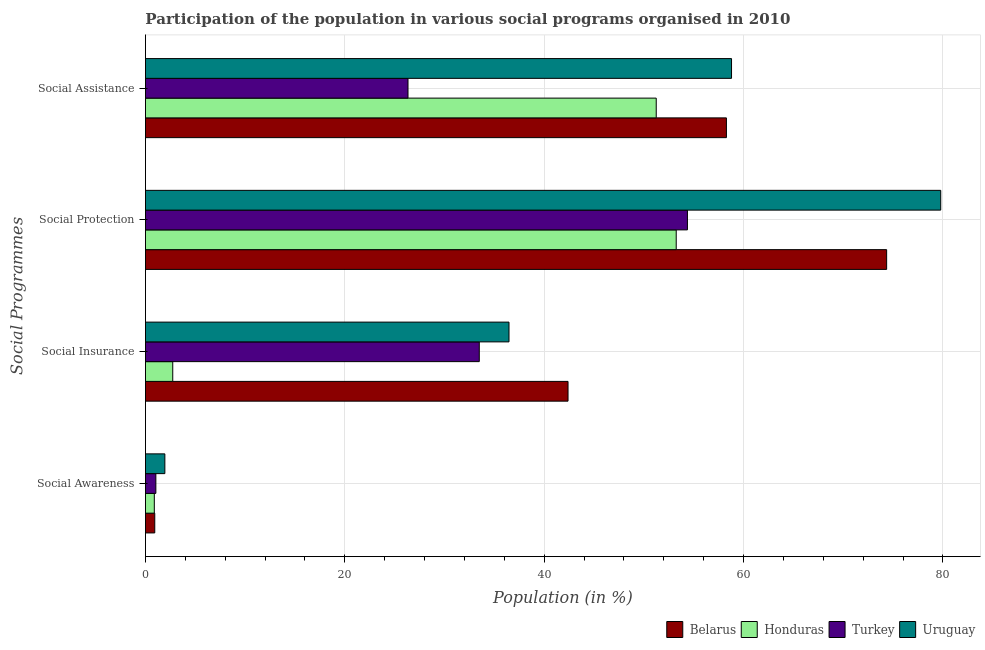How many different coloured bars are there?
Make the answer very short. 4. How many groups of bars are there?
Make the answer very short. 4. Are the number of bars per tick equal to the number of legend labels?
Offer a very short reply. Yes. Are the number of bars on each tick of the Y-axis equal?
Provide a succinct answer. Yes. How many bars are there on the 1st tick from the bottom?
Offer a very short reply. 4. What is the label of the 4th group of bars from the top?
Ensure brevity in your answer.  Social Awareness. What is the participation of population in social awareness programs in Belarus?
Your answer should be very brief. 0.93. Across all countries, what is the maximum participation of population in social assistance programs?
Provide a short and direct response. 58.79. Across all countries, what is the minimum participation of population in social insurance programs?
Provide a succinct answer. 2.74. In which country was the participation of population in social assistance programs maximum?
Your answer should be very brief. Uruguay. In which country was the participation of population in social protection programs minimum?
Your response must be concise. Honduras. What is the total participation of population in social insurance programs in the graph?
Provide a succinct answer. 115.08. What is the difference between the participation of population in social assistance programs in Uruguay and that in Turkey?
Offer a very short reply. 32.45. What is the difference between the participation of population in social protection programs in Belarus and the participation of population in social awareness programs in Turkey?
Ensure brevity in your answer.  73.31. What is the average participation of population in social protection programs per country?
Ensure brevity in your answer.  65.43. What is the difference between the participation of population in social assistance programs and participation of population in social insurance programs in Uruguay?
Make the answer very short. 22.32. What is the ratio of the participation of population in social assistance programs in Uruguay to that in Belarus?
Provide a short and direct response. 1.01. Is the difference between the participation of population in social insurance programs in Turkey and Uruguay greater than the difference between the participation of population in social awareness programs in Turkey and Uruguay?
Keep it short and to the point. No. What is the difference between the highest and the second highest participation of population in social protection programs?
Your answer should be very brief. 5.43. What is the difference between the highest and the lowest participation of population in social awareness programs?
Offer a very short reply. 1.06. Is the sum of the participation of population in social awareness programs in Belarus and Uruguay greater than the maximum participation of population in social assistance programs across all countries?
Your answer should be very brief. No. What does the 1st bar from the top in Social Awareness represents?
Offer a very short reply. Uruguay. What does the 4th bar from the bottom in Social Awareness represents?
Your answer should be very brief. Uruguay. Is it the case that in every country, the sum of the participation of population in social awareness programs and participation of population in social insurance programs is greater than the participation of population in social protection programs?
Provide a short and direct response. No. Are all the bars in the graph horizontal?
Give a very brief answer. Yes. How many countries are there in the graph?
Your answer should be very brief. 4. Does the graph contain any zero values?
Provide a succinct answer. No. Does the graph contain grids?
Ensure brevity in your answer.  Yes. Where does the legend appear in the graph?
Give a very brief answer. Bottom right. How are the legend labels stacked?
Ensure brevity in your answer.  Horizontal. What is the title of the graph?
Your answer should be compact. Participation of the population in various social programs organised in 2010. Does "Maldives" appear as one of the legend labels in the graph?
Offer a terse response. No. What is the label or title of the X-axis?
Keep it short and to the point. Population (in %). What is the label or title of the Y-axis?
Offer a very short reply. Social Programmes. What is the Population (in %) of Belarus in Social Awareness?
Provide a short and direct response. 0.93. What is the Population (in %) in Honduras in Social Awareness?
Offer a terse response. 0.89. What is the Population (in %) of Turkey in Social Awareness?
Your answer should be compact. 1.04. What is the Population (in %) in Uruguay in Social Awareness?
Your response must be concise. 1.95. What is the Population (in %) in Belarus in Social Insurance?
Your answer should be very brief. 42.39. What is the Population (in %) in Honduras in Social Insurance?
Keep it short and to the point. 2.74. What is the Population (in %) of Turkey in Social Insurance?
Give a very brief answer. 33.49. What is the Population (in %) in Uruguay in Social Insurance?
Your answer should be very brief. 36.47. What is the Population (in %) in Belarus in Social Protection?
Your answer should be compact. 74.35. What is the Population (in %) of Honduras in Social Protection?
Ensure brevity in your answer.  53.24. What is the Population (in %) of Turkey in Social Protection?
Your answer should be compact. 54.37. What is the Population (in %) in Uruguay in Social Protection?
Offer a terse response. 79.78. What is the Population (in %) in Belarus in Social Assistance?
Offer a very short reply. 58.28. What is the Population (in %) in Honduras in Social Assistance?
Ensure brevity in your answer.  51.24. What is the Population (in %) of Turkey in Social Assistance?
Offer a terse response. 26.34. What is the Population (in %) of Uruguay in Social Assistance?
Your answer should be very brief. 58.79. Across all Social Programmes, what is the maximum Population (in %) of Belarus?
Your answer should be compact. 74.35. Across all Social Programmes, what is the maximum Population (in %) of Honduras?
Your answer should be compact. 53.24. Across all Social Programmes, what is the maximum Population (in %) of Turkey?
Ensure brevity in your answer.  54.37. Across all Social Programmes, what is the maximum Population (in %) in Uruguay?
Offer a very short reply. 79.78. Across all Social Programmes, what is the minimum Population (in %) of Belarus?
Offer a very short reply. 0.93. Across all Social Programmes, what is the minimum Population (in %) in Honduras?
Ensure brevity in your answer.  0.89. Across all Social Programmes, what is the minimum Population (in %) of Turkey?
Make the answer very short. 1.04. Across all Social Programmes, what is the minimum Population (in %) in Uruguay?
Your response must be concise. 1.95. What is the total Population (in %) of Belarus in the graph?
Your answer should be very brief. 175.95. What is the total Population (in %) in Honduras in the graph?
Your answer should be compact. 108.11. What is the total Population (in %) in Turkey in the graph?
Your answer should be compact. 115.24. What is the total Population (in %) in Uruguay in the graph?
Keep it short and to the point. 176.98. What is the difference between the Population (in %) of Belarus in Social Awareness and that in Social Insurance?
Keep it short and to the point. -41.46. What is the difference between the Population (in %) of Honduras in Social Awareness and that in Social Insurance?
Your answer should be very brief. -1.85. What is the difference between the Population (in %) of Turkey in Social Awareness and that in Social Insurance?
Your response must be concise. -32.44. What is the difference between the Population (in %) of Uruguay in Social Awareness and that in Social Insurance?
Ensure brevity in your answer.  -34.52. What is the difference between the Population (in %) of Belarus in Social Awareness and that in Social Protection?
Keep it short and to the point. -73.42. What is the difference between the Population (in %) of Honduras in Social Awareness and that in Social Protection?
Offer a very short reply. -52.35. What is the difference between the Population (in %) in Turkey in Social Awareness and that in Social Protection?
Make the answer very short. -53.32. What is the difference between the Population (in %) of Uruguay in Social Awareness and that in Social Protection?
Your answer should be compact. -77.83. What is the difference between the Population (in %) in Belarus in Social Awareness and that in Social Assistance?
Offer a terse response. -57.34. What is the difference between the Population (in %) of Honduras in Social Awareness and that in Social Assistance?
Offer a terse response. -50.35. What is the difference between the Population (in %) of Turkey in Social Awareness and that in Social Assistance?
Your answer should be compact. -25.29. What is the difference between the Population (in %) of Uruguay in Social Awareness and that in Social Assistance?
Make the answer very short. -56.85. What is the difference between the Population (in %) in Belarus in Social Insurance and that in Social Protection?
Provide a succinct answer. -31.96. What is the difference between the Population (in %) in Honduras in Social Insurance and that in Social Protection?
Your answer should be compact. -50.5. What is the difference between the Population (in %) in Turkey in Social Insurance and that in Social Protection?
Provide a succinct answer. -20.88. What is the difference between the Population (in %) in Uruguay in Social Insurance and that in Social Protection?
Keep it short and to the point. -43.31. What is the difference between the Population (in %) of Belarus in Social Insurance and that in Social Assistance?
Give a very brief answer. -15.89. What is the difference between the Population (in %) of Honduras in Social Insurance and that in Social Assistance?
Your answer should be compact. -48.5. What is the difference between the Population (in %) of Turkey in Social Insurance and that in Social Assistance?
Your answer should be very brief. 7.15. What is the difference between the Population (in %) in Uruguay in Social Insurance and that in Social Assistance?
Offer a terse response. -22.32. What is the difference between the Population (in %) in Belarus in Social Protection and that in Social Assistance?
Provide a short and direct response. 16.07. What is the difference between the Population (in %) in Honduras in Social Protection and that in Social Assistance?
Keep it short and to the point. 2. What is the difference between the Population (in %) in Turkey in Social Protection and that in Social Assistance?
Provide a short and direct response. 28.03. What is the difference between the Population (in %) of Uruguay in Social Protection and that in Social Assistance?
Offer a terse response. 20.98. What is the difference between the Population (in %) of Belarus in Social Awareness and the Population (in %) of Honduras in Social Insurance?
Provide a short and direct response. -1.8. What is the difference between the Population (in %) of Belarus in Social Awareness and the Population (in %) of Turkey in Social Insurance?
Your answer should be compact. -32.55. What is the difference between the Population (in %) in Belarus in Social Awareness and the Population (in %) in Uruguay in Social Insurance?
Make the answer very short. -35.53. What is the difference between the Population (in %) in Honduras in Social Awareness and the Population (in %) in Turkey in Social Insurance?
Keep it short and to the point. -32.6. What is the difference between the Population (in %) of Honduras in Social Awareness and the Population (in %) of Uruguay in Social Insurance?
Provide a succinct answer. -35.58. What is the difference between the Population (in %) of Turkey in Social Awareness and the Population (in %) of Uruguay in Social Insurance?
Make the answer very short. -35.42. What is the difference between the Population (in %) of Belarus in Social Awareness and the Population (in %) of Honduras in Social Protection?
Provide a succinct answer. -52.31. What is the difference between the Population (in %) of Belarus in Social Awareness and the Population (in %) of Turkey in Social Protection?
Give a very brief answer. -53.43. What is the difference between the Population (in %) in Belarus in Social Awareness and the Population (in %) in Uruguay in Social Protection?
Keep it short and to the point. -78.84. What is the difference between the Population (in %) of Honduras in Social Awareness and the Population (in %) of Turkey in Social Protection?
Offer a terse response. -53.48. What is the difference between the Population (in %) in Honduras in Social Awareness and the Population (in %) in Uruguay in Social Protection?
Keep it short and to the point. -78.89. What is the difference between the Population (in %) of Turkey in Social Awareness and the Population (in %) of Uruguay in Social Protection?
Your answer should be very brief. -78.73. What is the difference between the Population (in %) in Belarus in Social Awareness and the Population (in %) in Honduras in Social Assistance?
Make the answer very short. -50.3. What is the difference between the Population (in %) of Belarus in Social Awareness and the Population (in %) of Turkey in Social Assistance?
Ensure brevity in your answer.  -25.4. What is the difference between the Population (in %) of Belarus in Social Awareness and the Population (in %) of Uruguay in Social Assistance?
Keep it short and to the point. -57.86. What is the difference between the Population (in %) of Honduras in Social Awareness and the Population (in %) of Turkey in Social Assistance?
Your answer should be very brief. -25.45. What is the difference between the Population (in %) of Honduras in Social Awareness and the Population (in %) of Uruguay in Social Assistance?
Your response must be concise. -57.9. What is the difference between the Population (in %) in Turkey in Social Awareness and the Population (in %) in Uruguay in Social Assistance?
Ensure brevity in your answer.  -57.75. What is the difference between the Population (in %) of Belarus in Social Insurance and the Population (in %) of Honduras in Social Protection?
Provide a succinct answer. -10.85. What is the difference between the Population (in %) in Belarus in Social Insurance and the Population (in %) in Turkey in Social Protection?
Ensure brevity in your answer.  -11.98. What is the difference between the Population (in %) of Belarus in Social Insurance and the Population (in %) of Uruguay in Social Protection?
Your answer should be compact. -37.39. What is the difference between the Population (in %) in Honduras in Social Insurance and the Population (in %) in Turkey in Social Protection?
Make the answer very short. -51.63. What is the difference between the Population (in %) of Honduras in Social Insurance and the Population (in %) of Uruguay in Social Protection?
Your response must be concise. -77.04. What is the difference between the Population (in %) of Turkey in Social Insurance and the Population (in %) of Uruguay in Social Protection?
Provide a succinct answer. -46.29. What is the difference between the Population (in %) in Belarus in Social Insurance and the Population (in %) in Honduras in Social Assistance?
Make the answer very short. -8.85. What is the difference between the Population (in %) in Belarus in Social Insurance and the Population (in %) in Turkey in Social Assistance?
Your response must be concise. 16.05. What is the difference between the Population (in %) of Belarus in Social Insurance and the Population (in %) of Uruguay in Social Assistance?
Your response must be concise. -16.4. What is the difference between the Population (in %) of Honduras in Social Insurance and the Population (in %) of Turkey in Social Assistance?
Make the answer very short. -23.6. What is the difference between the Population (in %) of Honduras in Social Insurance and the Population (in %) of Uruguay in Social Assistance?
Provide a succinct answer. -56.05. What is the difference between the Population (in %) in Turkey in Social Insurance and the Population (in %) in Uruguay in Social Assistance?
Provide a short and direct response. -25.3. What is the difference between the Population (in %) of Belarus in Social Protection and the Population (in %) of Honduras in Social Assistance?
Provide a short and direct response. 23.11. What is the difference between the Population (in %) of Belarus in Social Protection and the Population (in %) of Turkey in Social Assistance?
Provide a succinct answer. 48.01. What is the difference between the Population (in %) of Belarus in Social Protection and the Population (in %) of Uruguay in Social Assistance?
Keep it short and to the point. 15.56. What is the difference between the Population (in %) of Honduras in Social Protection and the Population (in %) of Turkey in Social Assistance?
Ensure brevity in your answer.  26.91. What is the difference between the Population (in %) of Honduras in Social Protection and the Population (in %) of Uruguay in Social Assistance?
Offer a very short reply. -5.55. What is the difference between the Population (in %) in Turkey in Social Protection and the Population (in %) in Uruguay in Social Assistance?
Ensure brevity in your answer.  -4.42. What is the average Population (in %) in Belarus per Social Programmes?
Offer a terse response. 43.99. What is the average Population (in %) in Honduras per Social Programmes?
Offer a terse response. 27.03. What is the average Population (in %) in Turkey per Social Programmes?
Your answer should be compact. 28.81. What is the average Population (in %) in Uruguay per Social Programmes?
Your answer should be compact. 44.25. What is the difference between the Population (in %) of Belarus and Population (in %) of Honduras in Social Awareness?
Provide a short and direct response. 0.04. What is the difference between the Population (in %) of Belarus and Population (in %) of Turkey in Social Awareness?
Your answer should be compact. -0.11. What is the difference between the Population (in %) of Belarus and Population (in %) of Uruguay in Social Awareness?
Your answer should be compact. -1.01. What is the difference between the Population (in %) of Honduras and Population (in %) of Turkey in Social Awareness?
Provide a short and direct response. -0.16. What is the difference between the Population (in %) in Honduras and Population (in %) in Uruguay in Social Awareness?
Provide a short and direct response. -1.06. What is the difference between the Population (in %) of Turkey and Population (in %) of Uruguay in Social Awareness?
Give a very brief answer. -0.9. What is the difference between the Population (in %) of Belarus and Population (in %) of Honduras in Social Insurance?
Offer a terse response. 39.65. What is the difference between the Population (in %) of Belarus and Population (in %) of Turkey in Social Insurance?
Provide a short and direct response. 8.9. What is the difference between the Population (in %) of Belarus and Population (in %) of Uruguay in Social Insurance?
Provide a succinct answer. 5.92. What is the difference between the Population (in %) in Honduras and Population (in %) in Turkey in Social Insurance?
Offer a very short reply. -30.75. What is the difference between the Population (in %) in Honduras and Population (in %) in Uruguay in Social Insurance?
Offer a very short reply. -33.73. What is the difference between the Population (in %) in Turkey and Population (in %) in Uruguay in Social Insurance?
Ensure brevity in your answer.  -2.98. What is the difference between the Population (in %) of Belarus and Population (in %) of Honduras in Social Protection?
Give a very brief answer. 21.11. What is the difference between the Population (in %) of Belarus and Population (in %) of Turkey in Social Protection?
Give a very brief answer. 19.98. What is the difference between the Population (in %) in Belarus and Population (in %) in Uruguay in Social Protection?
Make the answer very short. -5.43. What is the difference between the Population (in %) in Honduras and Population (in %) in Turkey in Social Protection?
Give a very brief answer. -1.13. What is the difference between the Population (in %) of Honduras and Population (in %) of Uruguay in Social Protection?
Make the answer very short. -26.53. What is the difference between the Population (in %) in Turkey and Population (in %) in Uruguay in Social Protection?
Provide a short and direct response. -25.41. What is the difference between the Population (in %) of Belarus and Population (in %) of Honduras in Social Assistance?
Provide a succinct answer. 7.04. What is the difference between the Population (in %) of Belarus and Population (in %) of Turkey in Social Assistance?
Provide a succinct answer. 31.94. What is the difference between the Population (in %) in Belarus and Population (in %) in Uruguay in Social Assistance?
Your answer should be very brief. -0.51. What is the difference between the Population (in %) in Honduras and Population (in %) in Turkey in Social Assistance?
Keep it short and to the point. 24.9. What is the difference between the Population (in %) of Honduras and Population (in %) of Uruguay in Social Assistance?
Ensure brevity in your answer.  -7.55. What is the difference between the Population (in %) of Turkey and Population (in %) of Uruguay in Social Assistance?
Provide a short and direct response. -32.45. What is the ratio of the Population (in %) of Belarus in Social Awareness to that in Social Insurance?
Keep it short and to the point. 0.02. What is the ratio of the Population (in %) of Honduras in Social Awareness to that in Social Insurance?
Keep it short and to the point. 0.32. What is the ratio of the Population (in %) in Turkey in Social Awareness to that in Social Insurance?
Offer a very short reply. 0.03. What is the ratio of the Population (in %) in Uruguay in Social Awareness to that in Social Insurance?
Ensure brevity in your answer.  0.05. What is the ratio of the Population (in %) in Belarus in Social Awareness to that in Social Protection?
Provide a succinct answer. 0.01. What is the ratio of the Population (in %) in Honduras in Social Awareness to that in Social Protection?
Your response must be concise. 0.02. What is the ratio of the Population (in %) of Turkey in Social Awareness to that in Social Protection?
Provide a succinct answer. 0.02. What is the ratio of the Population (in %) of Uruguay in Social Awareness to that in Social Protection?
Provide a succinct answer. 0.02. What is the ratio of the Population (in %) of Belarus in Social Awareness to that in Social Assistance?
Make the answer very short. 0.02. What is the ratio of the Population (in %) of Honduras in Social Awareness to that in Social Assistance?
Provide a short and direct response. 0.02. What is the ratio of the Population (in %) of Turkey in Social Awareness to that in Social Assistance?
Make the answer very short. 0.04. What is the ratio of the Population (in %) of Uruguay in Social Awareness to that in Social Assistance?
Offer a terse response. 0.03. What is the ratio of the Population (in %) in Belarus in Social Insurance to that in Social Protection?
Offer a very short reply. 0.57. What is the ratio of the Population (in %) in Honduras in Social Insurance to that in Social Protection?
Your answer should be very brief. 0.05. What is the ratio of the Population (in %) in Turkey in Social Insurance to that in Social Protection?
Your answer should be very brief. 0.62. What is the ratio of the Population (in %) in Uruguay in Social Insurance to that in Social Protection?
Keep it short and to the point. 0.46. What is the ratio of the Population (in %) in Belarus in Social Insurance to that in Social Assistance?
Your answer should be compact. 0.73. What is the ratio of the Population (in %) of Honduras in Social Insurance to that in Social Assistance?
Your answer should be compact. 0.05. What is the ratio of the Population (in %) of Turkey in Social Insurance to that in Social Assistance?
Your answer should be compact. 1.27. What is the ratio of the Population (in %) of Uruguay in Social Insurance to that in Social Assistance?
Ensure brevity in your answer.  0.62. What is the ratio of the Population (in %) in Belarus in Social Protection to that in Social Assistance?
Offer a terse response. 1.28. What is the ratio of the Population (in %) in Honduras in Social Protection to that in Social Assistance?
Provide a succinct answer. 1.04. What is the ratio of the Population (in %) in Turkey in Social Protection to that in Social Assistance?
Offer a very short reply. 2.06. What is the ratio of the Population (in %) in Uruguay in Social Protection to that in Social Assistance?
Make the answer very short. 1.36. What is the difference between the highest and the second highest Population (in %) in Belarus?
Give a very brief answer. 16.07. What is the difference between the highest and the second highest Population (in %) in Honduras?
Offer a terse response. 2. What is the difference between the highest and the second highest Population (in %) in Turkey?
Your answer should be compact. 20.88. What is the difference between the highest and the second highest Population (in %) in Uruguay?
Your answer should be compact. 20.98. What is the difference between the highest and the lowest Population (in %) in Belarus?
Keep it short and to the point. 73.42. What is the difference between the highest and the lowest Population (in %) in Honduras?
Offer a terse response. 52.35. What is the difference between the highest and the lowest Population (in %) in Turkey?
Your response must be concise. 53.32. What is the difference between the highest and the lowest Population (in %) in Uruguay?
Keep it short and to the point. 77.83. 